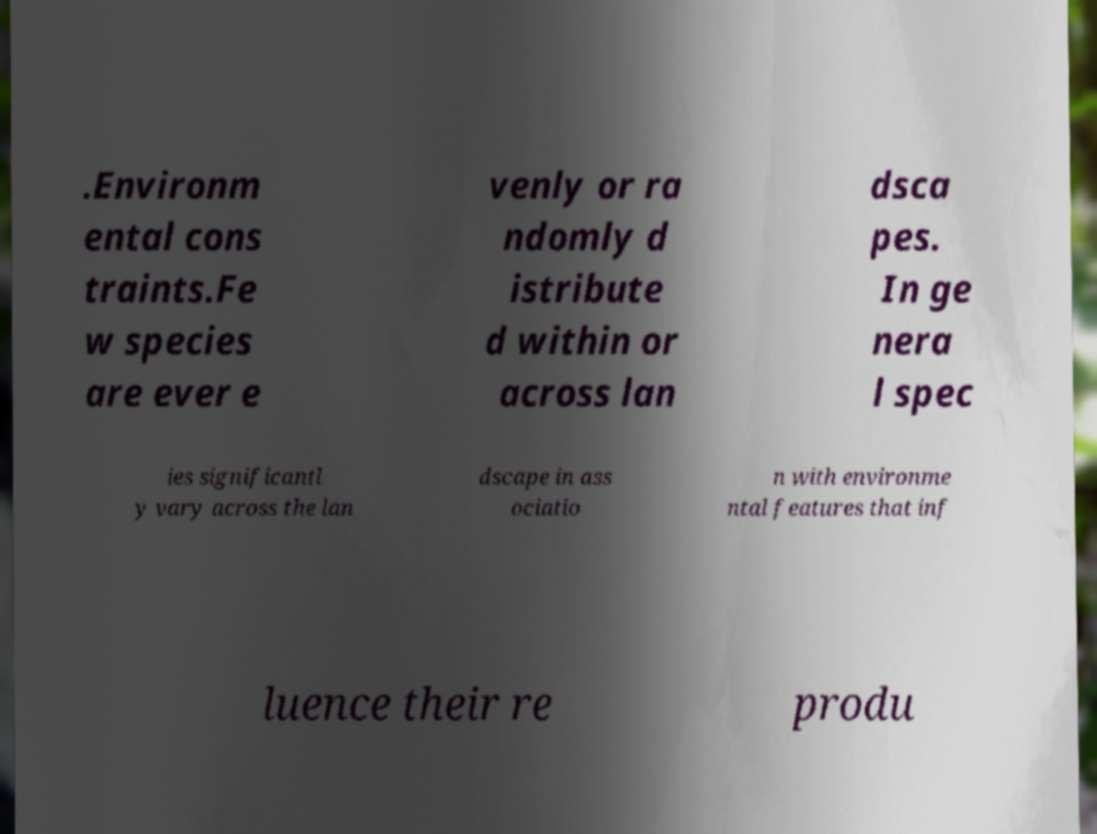Can you accurately transcribe the text from the provided image for me? .Environm ental cons traints.Fe w species are ever e venly or ra ndomly d istribute d within or across lan dsca pes. In ge nera l spec ies significantl y vary across the lan dscape in ass ociatio n with environme ntal features that inf luence their re produ 